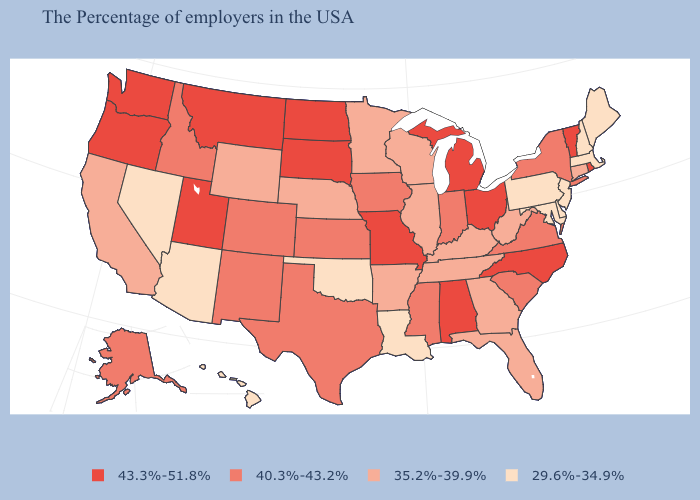What is the lowest value in states that border Maryland?
Short answer required. 29.6%-34.9%. Does New Mexico have the same value as Texas?
Short answer required. Yes. Does South Dakota have the highest value in the MidWest?
Write a very short answer. Yes. Which states have the lowest value in the USA?
Give a very brief answer. Maine, Massachusetts, New Hampshire, New Jersey, Delaware, Maryland, Pennsylvania, Louisiana, Oklahoma, Arizona, Nevada, Hawaii. Among the states that border New Jersey , does Delaware have the highest value?
Quick response, please. No. What is the value of Colorado?
Be succinct. 40.3%-43.2%. What is the highest value in the USA?
Answer briefly. 43.3%-51.8%. What is the highest value in states that border Minnesota?
Short answer required. 43.3%-51.8%. Which states hav the highest value in the West?
Concise answer only. Utah, Montana, Washington, Oregon. What is the value of Missouri?
Keep it brief. 43.3%-51.8%. Among the states that border Minnesota , which have the highest value?
Answer briefly. South Dakota, North Dakota. What is the highest value in states that border Oregon?
Answer briefly. 43.3%-51.8%. What is the value of Illinois?
Short answer required. 35.2%-39.9%. What is the lowest value in states that border Mississippi?
Keep it brief. 29.6%-34.9%. Name the states that have a value in the range 29.6%-34.9%?
Answer briefly. Maine, Massachusetts, New Hampshire, New Jersey, Delaware, Maryland, Pennsylvania, Louisiana, Oklahoma, Arizona, Nevada, Hawaii. 